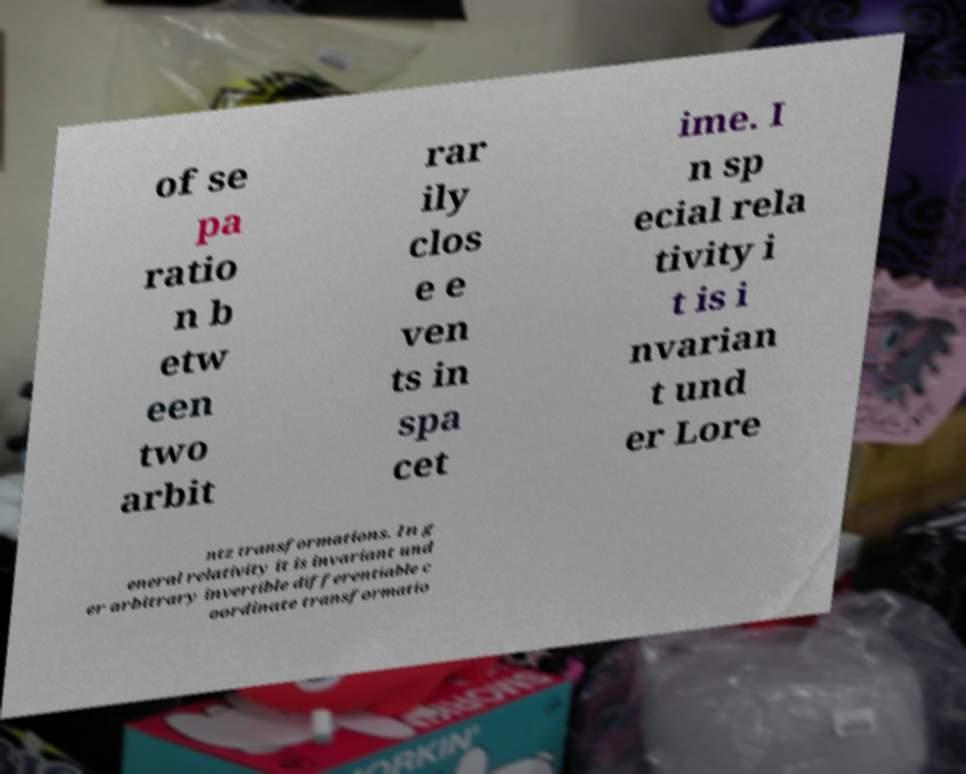Could you extract and type out the text from this image? of se pa ratio n b etw een two arbit rar ily clos e e ven ts in spa cet ime. I n sp ecial rela tivity i t is i nvarian t und er Lore ntz transformations. In g eneral relativity it is invariant und er arbitrary invertible differentiable c oordinate transformatio 